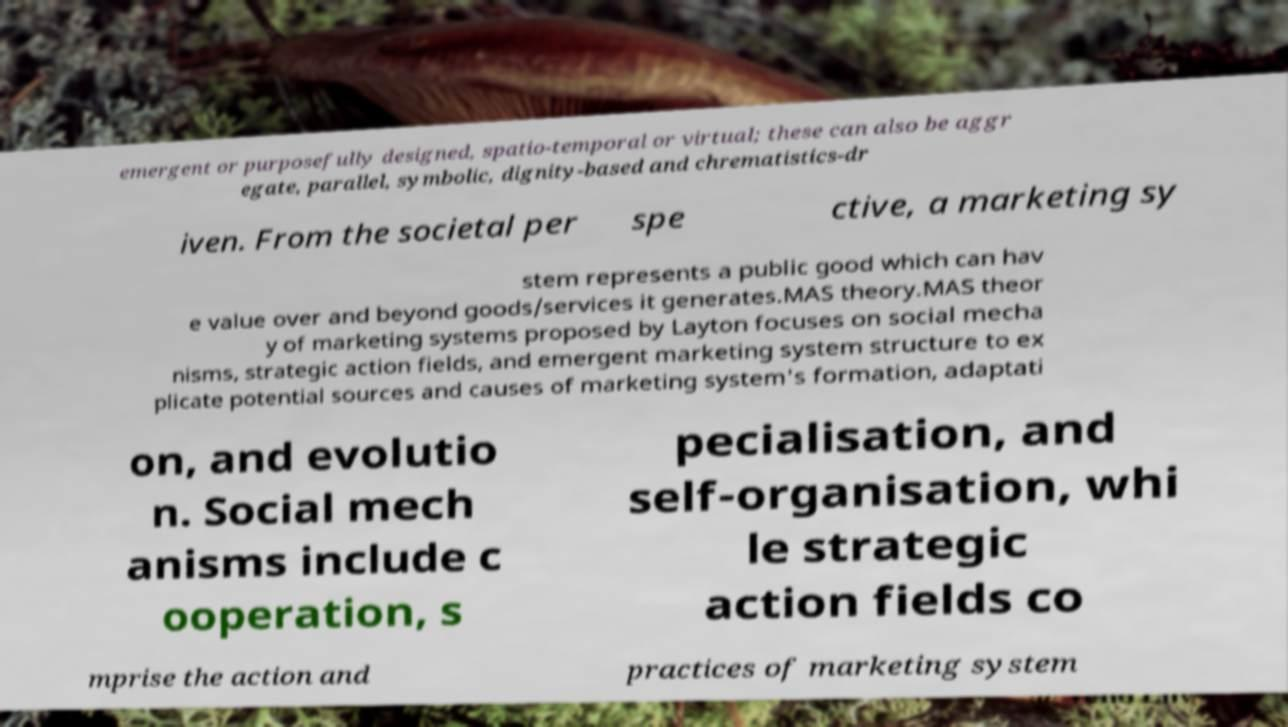Could you assist in decoding the text presented in this image and type it out clearly? emergent or purposefully designed, spatio-temporal or virtual; these can also be aggr egate, parallel, symbolic, dignity-based and chrematistics-dr iven. From the societal per spe ctive, a marketing sy stem represents a public good which can hav e value over and beyond goods/services it generates.MAS theory.MAS theor y of marketing systems proposed by Layton focuses on social mecha nisms, strategic action fields, and emergent marketing system structure to ex plicate potential sources and causes of marketing system's formation, adaptati on, and evolutio n. Social mech anisms include c ooperation, s pecialisation, and self-organisation, whi le strategic action fields co mprise the action and practices of marketing system 